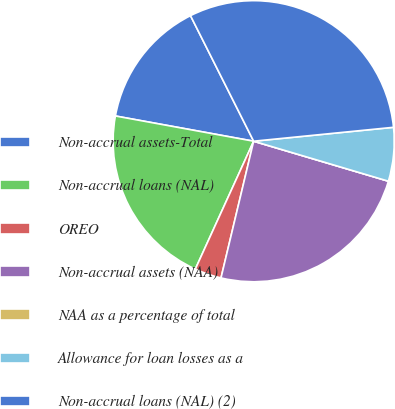Convert chart. <chart><loc_0><loc_0><loc_500><loc_500><pie_chart><fcel>Non-accrual assets-Total<fcel>Non-accrual loans (NAL)<fcel>OREO<fcel>Non-accrual assets (NAA)<fcel>NAA as a percentage of total<fcel>Allowance for loan losses as a<fcel>Non-accrual loans (NAL) (2)<nl><fcel>14.71%<fcel>21.06%<fcel>3.08%<fcel>24.14%<fcel>0.0%<fcel>6.17%<fcel>30.84%<nl></chart> 